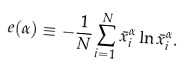<formula> <loc_0><loc_0><loc_500><loc_500>e ( \alpha ) \equiv - \frac { 1 } { N } \sum _ { i = 1 } ^ { N } \bar { x } _ { i } ^ { \alpha } \ln \bar { x } _ { i } ^ { \alpha } .</formula> 